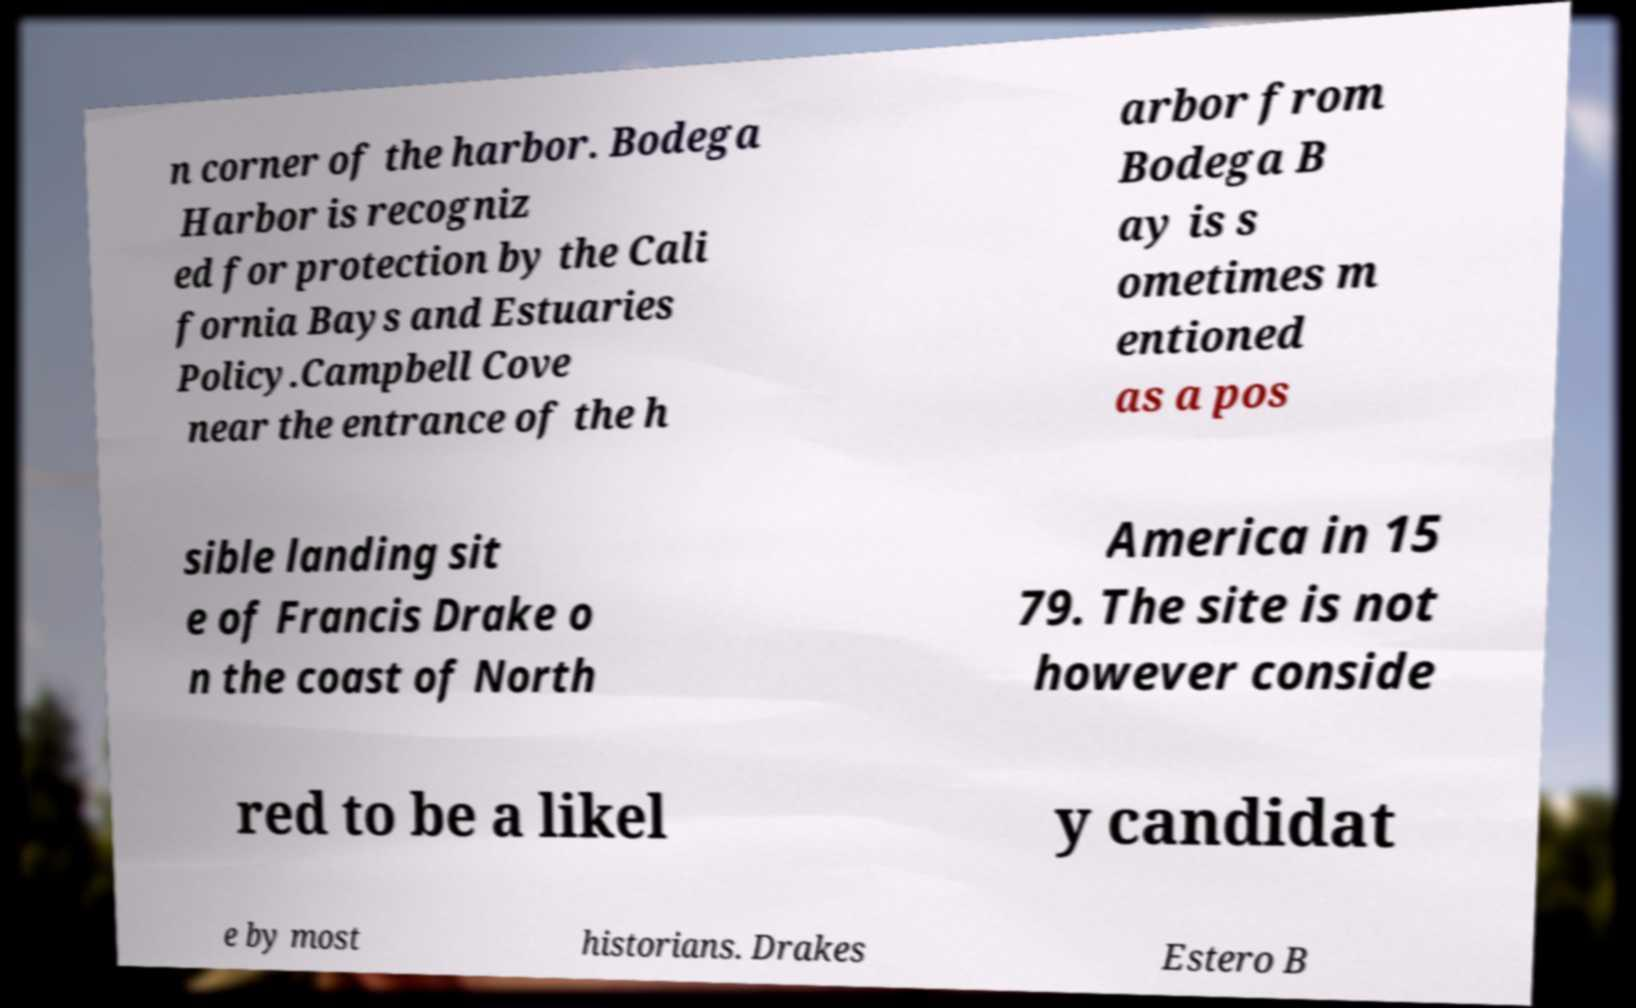There's text embedded in this image that I need extracted. Can you transcribe it verbatim? n corner of the harbor. Bodega Harbor is recogniz ed for protection by the Cali fornia Bays and Estuaries Policy.Campbell Cove near the entrance of the h arbor from Bodega B ay is s ometimes m entioned as a pos sible landing sit e of Francis Drake o n the coast of North America in 15 79. The site is not however conside red to be a likel y candidat e by most historians. Drakes Estero B 